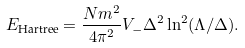<formula> <loc_0><loc_0><loc_500><loc_500>E _ { \text {Hartree} } = \frac { N m ^ { 2 } } { 4 \pi ^ { 2 } } V _ { - } \Delta ^ { 2 } \ln ^ { 2 } ( \Lambda / \Delta ) .</formula> 